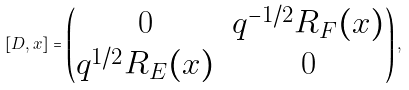<formula> <loc_0><loc_0><loc_500><loc_500>[ D , x ] = \left ( \begin{matrix} 0 & q ^ { - 1 / 2 } R _ { F } ( x ) \\ q ^ { 1 / 2 } R _ { E } ( x ) & 0 \end{matrix} \right ) ,</formula> 